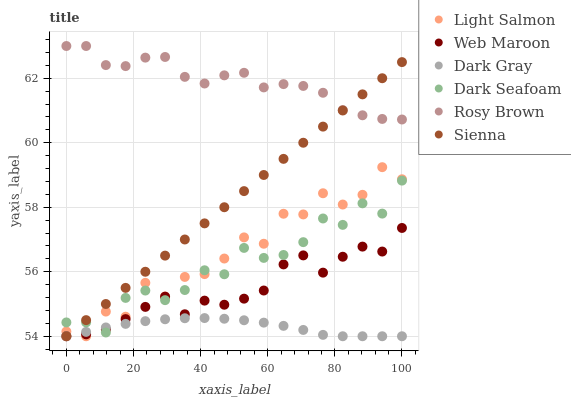Does Dark Gray have the minimum area under the curve?
Answer yes or no. Yes. Does Rosy Brown have the maximum area under the curve?
Answer yes or no. Yes. Does Light Salmon have the minimum area under the curve?
Answer yes or no. No. Does Light Salmon have the maximum area under the curve?
Answer yes or no. No. Is Sienna the smoothest?
Answer yes or no. Yes. Is Light Salmon the roughest?
Answer yes or no. Yes. Is Rosy Brown the smoothest?
Answer yes or no. No. Is Rosy Brown the roughest?
Answer yes or no. No. Does Sienna have the lowest value?
Answer yes or no. Yes. Does Rosy Brown have the lowest value?
Answer yes or no. No. Does Rosy Brown have the highest value?
Answer yes or no. Yes. Does Light Salmon have the highest value?
Answer yes or no. No. Is Light Salmon less than Rosy Brown?
Answer yes or no. Yes. Is Rosy Brown greater than Light Salmon?
Answer yes or no. Yes. Does Light Salmon intersect Web Maroon?
Answer yes or no. Yes. Is Light Salmon less than Web Maroon?
Answer yes or no. No. Is Light Salmon greater than Web Maroon?
Answer yes or no. No. Does Light Salmon intersect Rosy Brown?
Answer yes or no. No. 